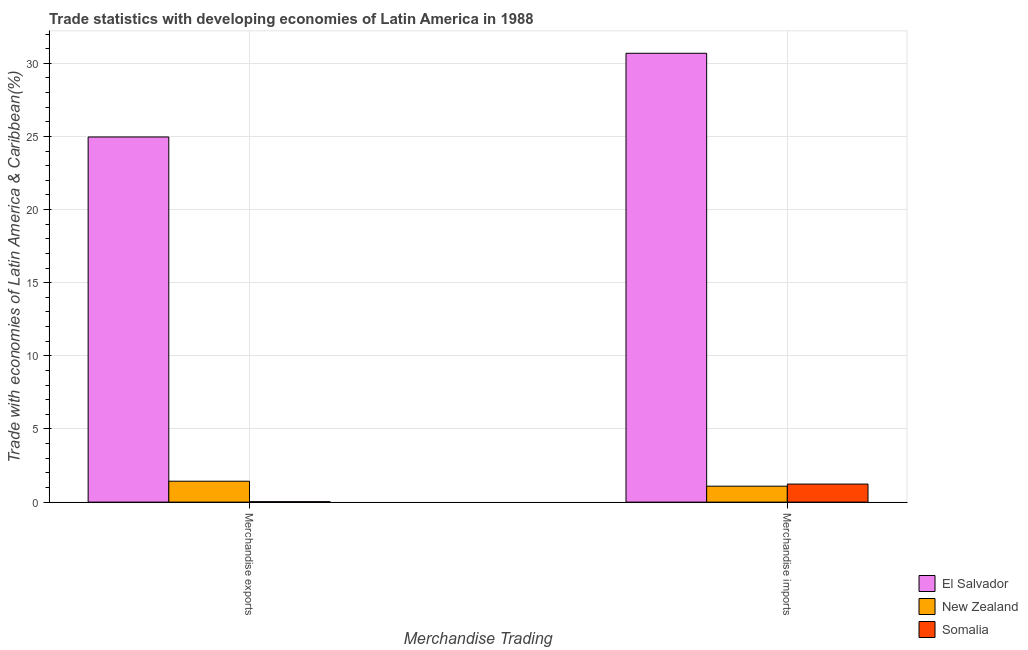How many groups of bars are there?
Ensure brevity in your answer.  2. Are the number of bars per tick equal to the number of legend labels?
Keep it short and to the point. Yes. What is the merchandise imports in New Zealand?
Keep it short and to the point. 1.09. Across all countries, what is the maximum merchandise exports?
Your answer should be very brief. 24.96. Across all countries, what is the minimum merchandise imports?
Your answer should be compact. 1.09. In which country was the merchandise imports maximum?
Your answer should be very brief. El Salvador. In which country was the merchandise exports minimum?
Keep it short and to the point. Somalia. What is the total merchandise imports in the graph?
Ensure brevity in your answer.  33.01. What is the difference between the merchandise exports in El Salvador and that in New Zealand?
Make the answer very short. 23.53. What is the difference between the merchandise exports in Somalia and the merchandise imports in New Zealand?
Offer a very short reply. -1.06. What is the average merchandise imports per country?
Offer a terse response. 11. What is the difference between the merchandise imports and merchandise exports in El Salvador?
Offer a terse response. 5.72. What is the ratio of the merchandise imports in El Salvador to that in Somalia?
Your answer should be compact. 24.85. Is the merchandise imports in El Salvador less than that in Somalia?
Offer a terse response. No. What does the 2nd bar from the left in Merchandise imports represents?
Ensure brevity in your answer.  New Zealand. What does the 1st bar from the right in Merchandise exports represents?
Your answer should be compact. Somalia. How many bars are there?
Your answer should be compact. 6. Are the values on the major ticks of Y-axis written in scientific E-notation?
Offer a very short reply. No. Does the graph contain grids?
Keep it short and to the point. Yes. Where does the legend appear in the graph?
Keep it short and to the point. Bottom right. How many legend labels are there?
Provide a succinct answer. 3. How are the legend labels stacked?
Give a very brief answer. Vertical. What is the title of the graph?
Make the answer very short. Trade statistics with developing economies of Latin America in 1988. Does "North America" appear as one of the legend labels in the graph?
Offer a terse response. No. What is the label or title of the X-axis?
Give a very brief answer. Merchandise Trading. What is the label or title of the Y-axis?
Provide a succinct answer. Trade with economies of Latin America & Caribbean(%). What is the Trade with economies of Latin America & Caribbean(%) in El Salvador in Merchandise exports?
Provide a succinct answer. 24.96. What is the Trade with economies of Latin America & Caribbean(%) in New Zealand in Merchandise exports?
Provide a succinct answer. 1.43. What is the Trade with economies of Latin America & Caribbean(%) in Somalia in Merchandise exports?
Offer a terse response. 0.03. What is the Trade with economies of Latin America & Caribbean(%) of El Salvador in Merchandise imports?
Your answer should be compact. 30.68. What is the Trade with economies of Latin America & Caribbean(%) in New Zealand in Merchandise imports?
Ensure brevity in your answer.  1.09. What is the Trade with economies of Latin America & Caribbean(%) of Somalia in Merchandise imports?
Make the answer very short. 1.23. Across all Merchandise Trading, what is the maximum Trade with economies of Latin America & Caribbean(%) in El Salvador?
Offer a very short reply. 30.68. Across all Merchandise Trading, what is the maximum Trade with economies of Latin America & Caribbean(%) in New Zealand?
Provide a short and direct response. 1.43. Across all Merchandise Trading, what is the maximum Trade with economies of Latin America & Caribbean(%) of Somalia?
Ensure brevity in your answer.  1.23. Across all Merchandise Trading, what is the minimum Trade with economies of Latin America & Caribbean(%) of El Salvador?
Provide a succinct answer. 24.96. Across all Merchandise Trading, what is the minimum Trade with economies of Latin America & Caribbean(%) in New Zealand?
Offer a very short reply. 1.09. Across all Merchandise Trading, what is the minimum Trade with economies of Latin America & Caribbean(%) of Somalia?
Your answer should be very brief. 0.03. What is the total Trade with economies of Latin America & Caribbean(%) of El Salvador in the graph?
Give a very brief answer. 55.64. What is the total Trade with economies of Latin America & Caribbean(%) of New Zealand in the graph?
Provide a succinct answer. 2.52. What is the total Trade with economies of Latin America & Caribbean(%) in Somalia in the graph?
Give a very brief answer. 1.26. What is the difference between the Trade with economies of Latin America & Caribbean(%) in El Salvador in Merchandise exports and that in Merchandise imports?
Ensure brevity in your answer.  -5.72. What is the difference between the Trade with economies of Latin America & Caribbean(%) of New Zealand in Merchandise exports and that in Merchandise imports?
Your answer should be compact. 0.34. What is the difference between the Trade with economies of Latin America & Caribbean(%) in Somalia in Merchandise exports and that in Merchandise imports?
Offer a terse response. -1.21. What is the difference between the Trade with economies of Latin America & Caribbean(%) of El Salvador in Merchandise exports and the Trade with economies of Latin America & Caribbean(%) of New Zealand in Merchandise imports?
Give a very brief answer. 23.87. What is the difference between the Trade with economies of Latin America & Caribbean(%) in El Salvador in Merchandise exports and the Trade with economies of Latin America & Caribbean(%) in Somalia in Merchandise imports?
Offer a terse response. 23.73. What is the difference between the Trade with economies of Latin America & Caribbean(%) in New Zealand in Merchandise exports and the Trade with economies of Latin America & Caribbean(%) in Somalia in Merchandise imports?
Your response must be concise. 0.2. What is the average Trade with economies of Latin America & Caribbean(%) of El Salvador per Merchandise Trading?
Provide a succinct answer. 27.82. What is the average Trade with economies of Latin America & Caribbean(%) in New Zealand per Merchandise Trading?
Your response must be concise. 1.26. What is the average Trade with economies of Latin America & Caribbean(%) in Somalia per Merchandise Trading?
Make the answer very short. 0.63. What is the difference between the Trade with economies of Latin America & Caribbean(%) in El Salvador and Trade with economies of Latin America & Caribbean(%) in New Zealand in Merchandise exports?
Your response must be concise. 23.53. What is the difference between the Trade with economies of Latin America & Caribbean(%) of El Salvador and Trade with economies of Latin America & Caribbean(%) of Somalia in Merchandise exports?
Provide a succinct answer. 24.93. What is the difference between the Trade with economies of Latin America & Caribbean(%) in New Zealand and Trade with economies of Latin America & Caribbean(%) in Somalia in Merchandise exports?
Your answer should be compact. 1.4. What is the difference between the Trade with economies of Latin America & Caribbean(%) of El Salvador and Trade with economies of Latin America & Caribbean(%) of New Zealand in Merchandise imports?
Offer a very short reply. 29.59. What is the difference between the Trade with economies of Latin America & Caribbean(%) of El Salvador and Trade with economies of Latin America & Caribbean(%) of Somalia in Merchandise imports?
Your answer should be very brief. 29.45. What is the difference between the Trade with economies of Latin America & Caribbean(%) of New Zealand and Trade with economies of Latin America & Caribbean(%) of Somalia in Merchandise imports?
Your response must be concise. -0.14. What is the ratio of the Trade with economies of Latin America & Caribbean(%) of El Salvador in Merchandise exports to that in Merchandise imports?
Your answer should be very brief. 0.81. What is the ratio of the Trade with economies of Latin America & Caribbean(%) of New Zealand in Merchandise exports to that in Merchandise imports?
Offer a very short reply. 1.31. What is the ratio of the Trade with economies of Latin America & Caribbean(%) of Somalia in Merchandise exports to that in Merchandise imports?
Ensure brevity in your answer.  0.02. What is the difference between the highest and the second highest Trade with economies of Latin America & Caribbean(%) of El Salvador?
Provide a short and direct response. 5.72. What is the difference between the highest and the second highest Trade with economies of Latin America & Caribbean(%) in New Zealand?
Provide a short and direct response. 0.34. What is the difference between the highest and the second highest Trade with economies of Latin America & Caribbean(%) of Somalia?
Offer a terse response. 1.21. What is the difference between the highest and the lowest Trade with economies of Latin America & Caribbean(%) of El Salvador?
Provide a short and direct response. 5.72. What is the difference between the highest and the lowest Trade with economies of Latin America & Caribbean(%) in New Zealand?
Provide a short and direct response. 0.34. What is the difference between the highest and the lowest Trade with economies of Latin America & Caribbean(%) of Somalia?
Provide a short and direct response. 1.21. 